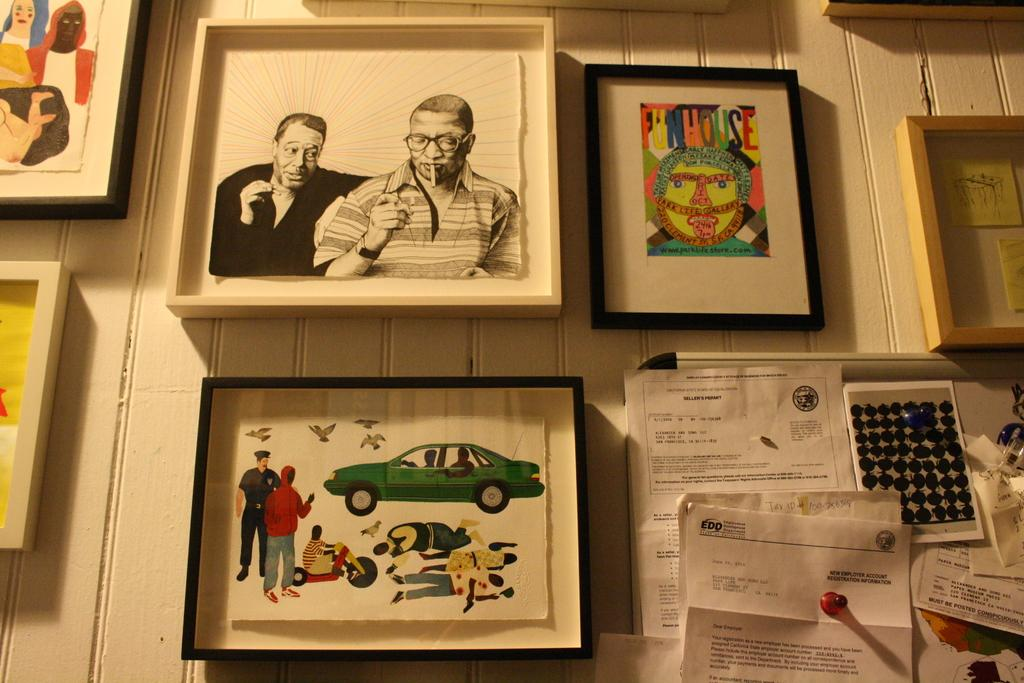What is hanging on the wall in the image? There is a group of photo frames on the wall. What can be seen in the bottom right of the image? There are papers with text attached to a board in the bottom right of the image. What type of pump can be seen in the image? There is no pump present in the image. 